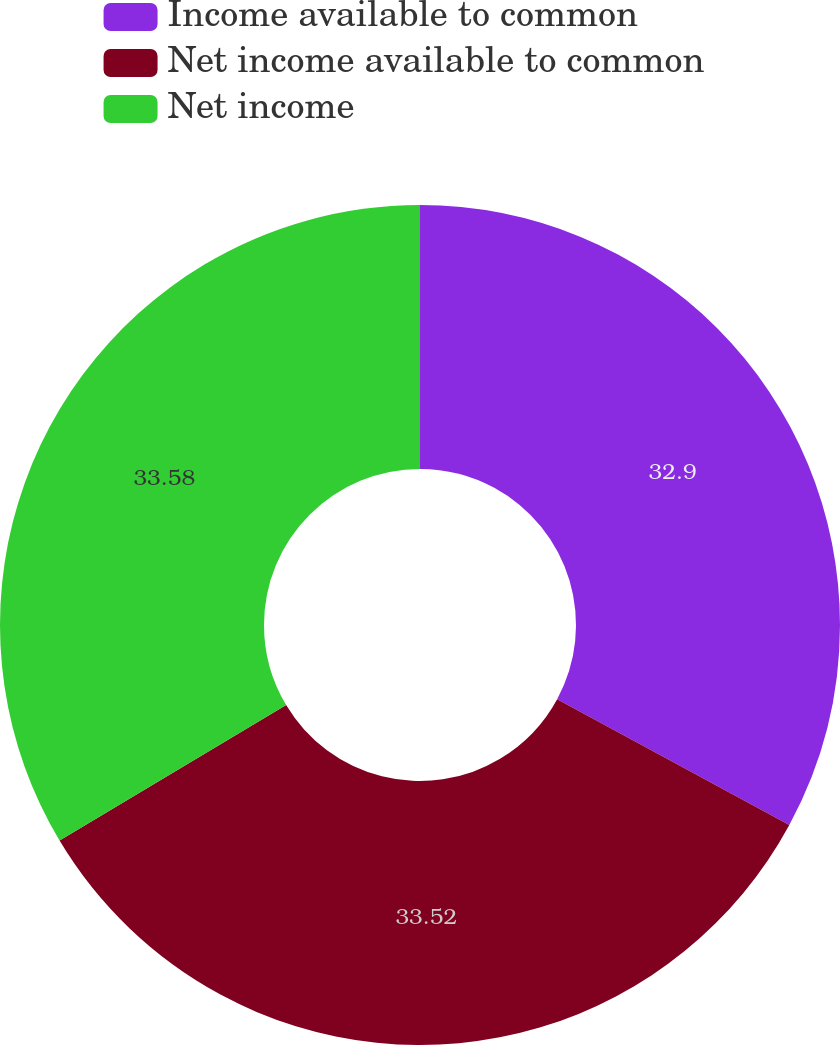Convert chart. <chart><loc_0><loc_0><loc_500><loc_500><pie_chart><fcel>Income available to common<fcel>Net income available to common<fcel>Net income<nl><fcel>32.9%<fcel>33.52%<fcel>33.58%<nl></chart> 